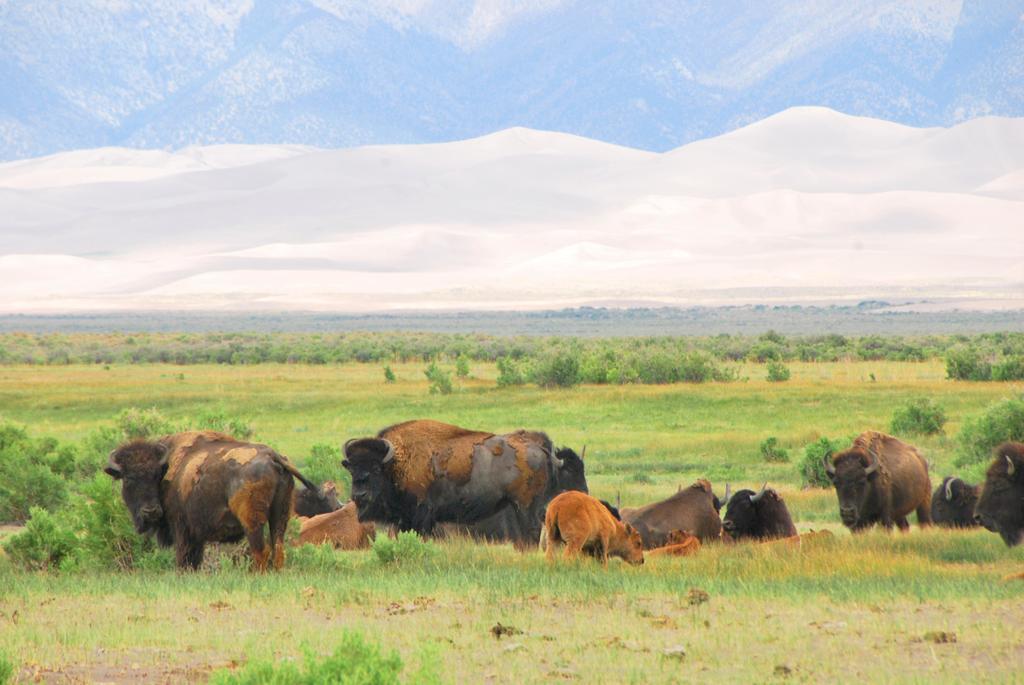Could you give a brief overview of what you see in this image? There is a land covered with many plants and grass, on the land there are few oxen. In the background there are many other trees and mountains. 